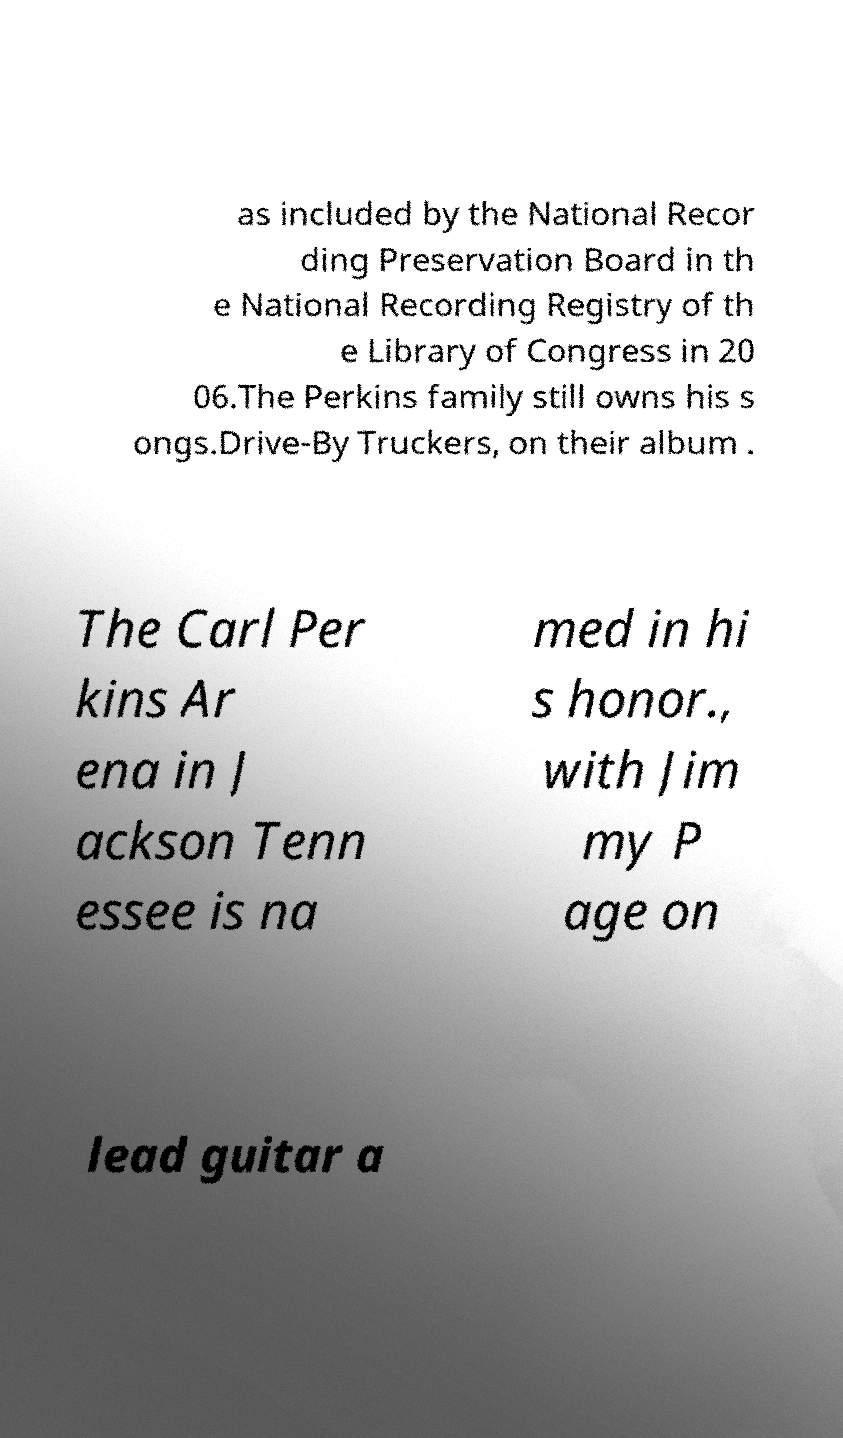I need the written content from this picture converted into text. Can you do that? as included by the National Recor ding Preservation Board in th e National Recording Registry of th e Library of Congress in 20 06.The Perkins family still owns his s ongs.Drive-By Truckers, on their album . The Carl Per kins Ar ena in J ackson Tenn essee is na med in hi s honor., with Jim my P age on lead guitar a 